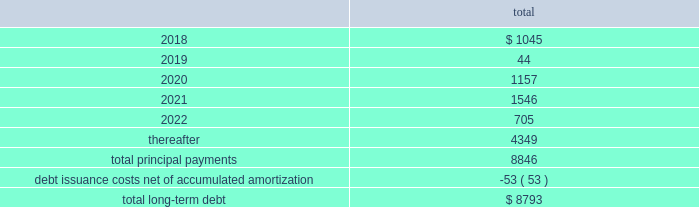Fidelity national information services , inc .
And subsidiaries notes to consolidated financial statements - ( continued ) the following summarizes the aggregate maturities of our debt and capital leases on stated contractual maturities , excluding unamortized non-cash bond premiums and discounts net of $ 30 million as of december 31 , 2017 ( in millions ) : .
There are no mandatory principal payments on the revolving loan and any balance outstanding on the revolving loan will be due and payable at its scheduled maturity date , which occurs at august 10 , 2021 .
Fis may redeem the 2018 notes , 2020 notes , 2021 notes , 2021 euro notes , 2022 notes , 2022 gbp notes , 2023 notes , 2024 notes , 2024 euro notes , 2025 notes , 2026 notes , and 2046 notes at its option in whole or in part , at any time and from time to time , at a redemption price equal to the greater of 100% ( 100 % ) of the principal amount to be redeemed and a make-whole amount calculated as described in the related indenture in each case plus accrued and unpaid interest to , but excluding , the date of redemption , provided no make-whole amount will be paid for redemptions of the 2020 notes , the 2021 notes , the 2021 euro notes and the 2022 gbp notes during the one month prior to their maturity , the 2022 notes during the two months prior to their maturity , the 2023 notes , the 2024 notes , the 2024 euro notes , the 2025 notes , and the 2026 notes during the three months prior to their maturity , and the 2046 notes during the six months prior to their maturity .
Debt issuance costs of $ 53 million , net of accumulated amortization , remain capitalized as of december 31 , 2017 , related to all of the above outstanding debt .
We monitor the financial stability of our counterparties on an ongoing basis .
The lender commitments under the undrawn portions of the revolving loan are comprised of a diversified set of financial institutions , both domestic and international .
The failure of any single lender to perform its obligations under the revolving loan would not adversely impact our ability to fund operations .
The fair value of the company 2019s long-term debt is estimated to be approximately $ 156 million higher than the carrying value as of december 31 , 2017 .
This estimate is based on quoted prices of our senior notes and trades of our other debt in close proximity to december 31 , 2017 , which are considered level 2-type measurements .
This estimate is subjective in nature and involves uncertainties and significant judgment in the interpretation of current market data .
Therefore , the values presented are not necessarily indicative of amounts the company could realize or settle currently. .
What is the amount of long-term debt that should be reported in the non-current liabilities section of the balance sheet as of december 31 , 2017? 
Computations: (8793 - 1045)
Answer: 7748.0. 